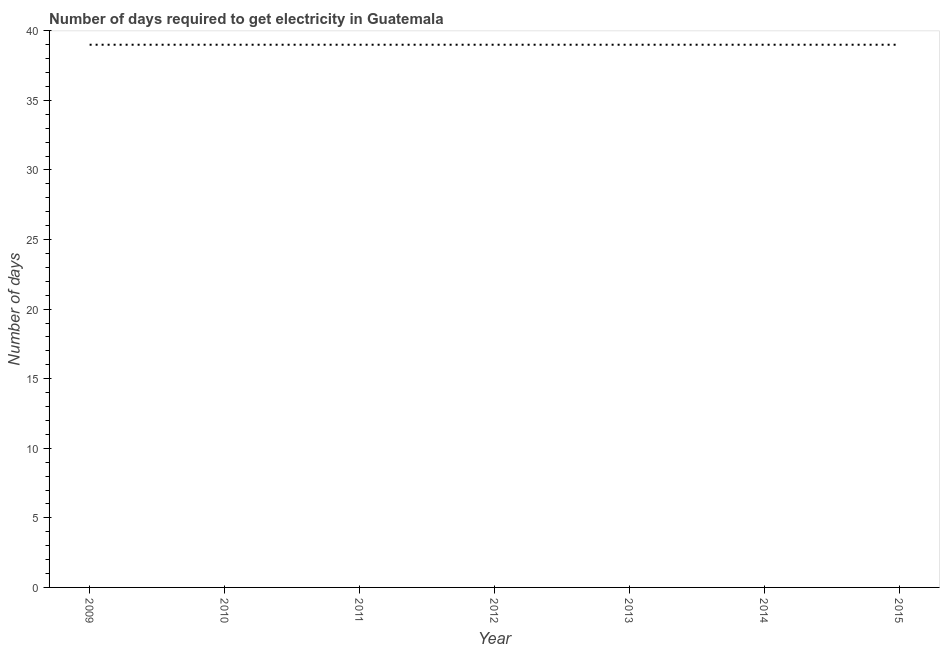What is the time to get electricity in 2010?
Keep it short and to the point. 39. Across all years, what is the maximum time to get electricity?
Provide a short and direct response. 39. Across all years, what is the minimum time to get electricity?
Offer a very short reply. 39. In which year was the time to get electricity minimum?
Your answer should be very brief. 2009. What is the sum of the time to get electricity?
Provide a succinct answer. 273. What is the difference between the time to get electricity in 2009 and 2010?
Your answer should be compact. 0. What is the average time to get electricity per year?
Your response must be concise. 39. What is the median time to get electricity?
Provide a short and direct response. 39. Do a majority of the years between 2009 and 2015 (inclusive) have time to get electricity greater than 30 ?
Offer a terse response. Yes. What is the ratio of the time to get electricity in 2009 to that in 2010?
Make the answer very short. 1. Is the sum of the time to get electricity in 2011 and 2013 greater than the maximum time to get electricity across all years?
Give a very brief answer. Yes. What is the difference between the highest and the lowest time to get electricity?
Your response must be concise. 0. How many years are there in the graph?
Provide a succinct answer. 7. What is the title of the graph?
Provide a short and direct response. Number of days required to get electricity in Guatemala. What is the label or title of the Y-axis?
Your response must be concise. Number of days. What is the Number of days of 2010?
Give a very brief answer. 39. What is the Number of days of 2012?
Ensure brevity in your answer.  39. What is the Number of days of 2013?
Provide a succinct answer. 39. What is the Number of days of 2015?
Provide a succinct answer. 39. What is the difference between the Number of days in 2009 and 2011?
Give a very brief answer. 0. What is the difference between the Number of days in 2009 and 2014?
Your answer should be compact. 0. What is the difference between the Number of days in 2009 and 2015?
Provide a succinct answer. 0. What is the difference between the Number of days in 2010 and 2012?
Your response must be concise. 0. What is the difference between the Number of days in 2010 and 2014?
Your answer should be very brief. 0. What is the difference between the Number of days in 2011 and 2013?
Keep it short and to the point. 0. What is the difference between the Number of days in 2011 and 2015?
Your answer should be compact. 0. What is the difference between the Number of days in 2012 and 2013?
Give a very brief answer. 0. What is the difference between the Number of days in 2013 and 2014?
Your response must be concise. 0. What is the ratio of the Number of days in 2009 to that in 2010?
Provide a short and direct response. 1. What is the ratio of the Number of days in 2009 to that in 2012?
Give a very brief answer. 1. What is the ratio of the Number of days in 2009 to that in 2013?
Offer a terse response. 1. What is the ratio of the Number of days in 2009 to that in 2014?
Keep it short and to the point. 1. What is the ratio of the Number of days in 2009 to that in 2015?
Your response must be concise. 1. What is the ratio of the Number of days in 2010 to that in 2014?
Provide a succinct answer. 1. What is the ratio of the Number of days in 2010 to that in 2015?
Your answer should be compact. 1. What is the ratio of the Number of days in 2011 to that in 2012?
Give a very brief answer. 1. What is the ratio of the Number of days in 2011 to that in 2014?
Ensure brevity in your answer.  1. What is the ratio of the Number of days in 2011 to that in 2015?
Make the answer very short. 1. What is the ratio of the Number of days in 2013 to that in 2015?
Make the answer very short. 1. 